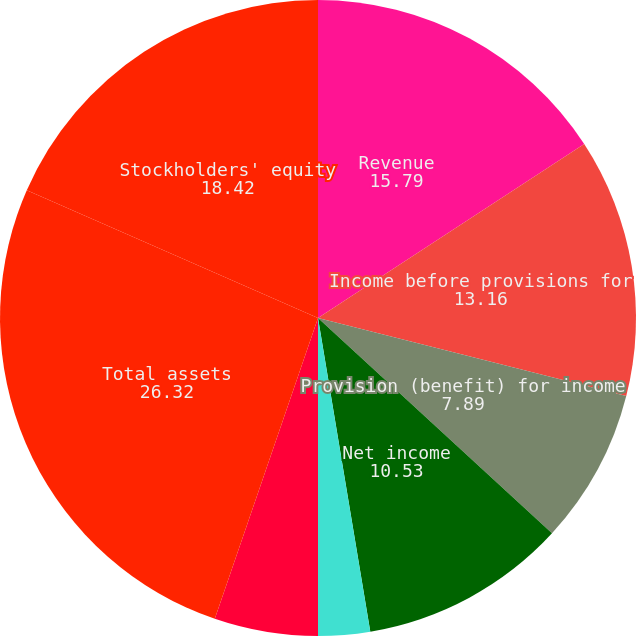Convert chart. <chart><loc_0><loc_0><loc_500><loc_500><pie_chart><fcel>Revenue<fcel>Income before provisions for<fcel>Provision (benefit) for income<fcel>Net income<fcel>Basic<fcel>Diluted<fcel>Working capital(3)<fcel>Total assets<fcel>Stockholders' equity<nl><fcel>15.79%<fcel>13.16%<fcel>7.89%<fcel>10.53%<fcel>2.63%<fcel>0.0%<fcel>5.26%<fcel>26.32%<fcel>18.42%<nl></chart> 